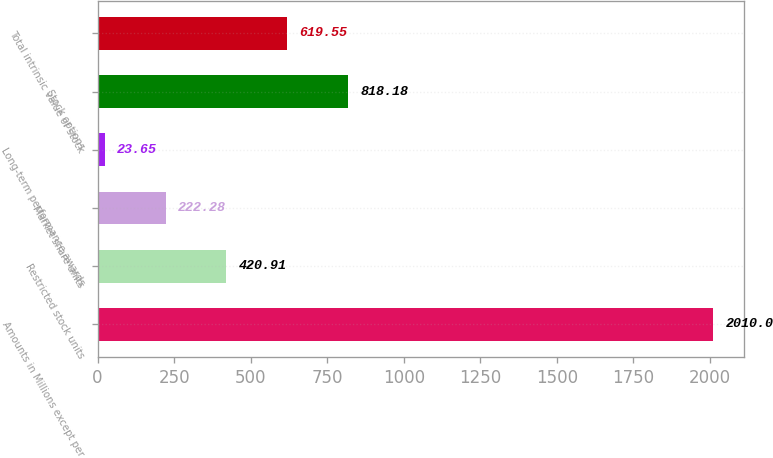<chart> <loc_0><loc_0><loc_500><loc_500><bar_chart><fcel>Amounts in Millions except per<fcel>Restricted stock units<fcel>Market share units<fcel>Long-term performance awards<fcel>Stock options<fcel>Total intrinsic value of stock<nl><fcel>2010<fcel>420.91<fcel>222.28<fcel>23.65<fcel>818.18<fcel>619.55<nl></chart> 